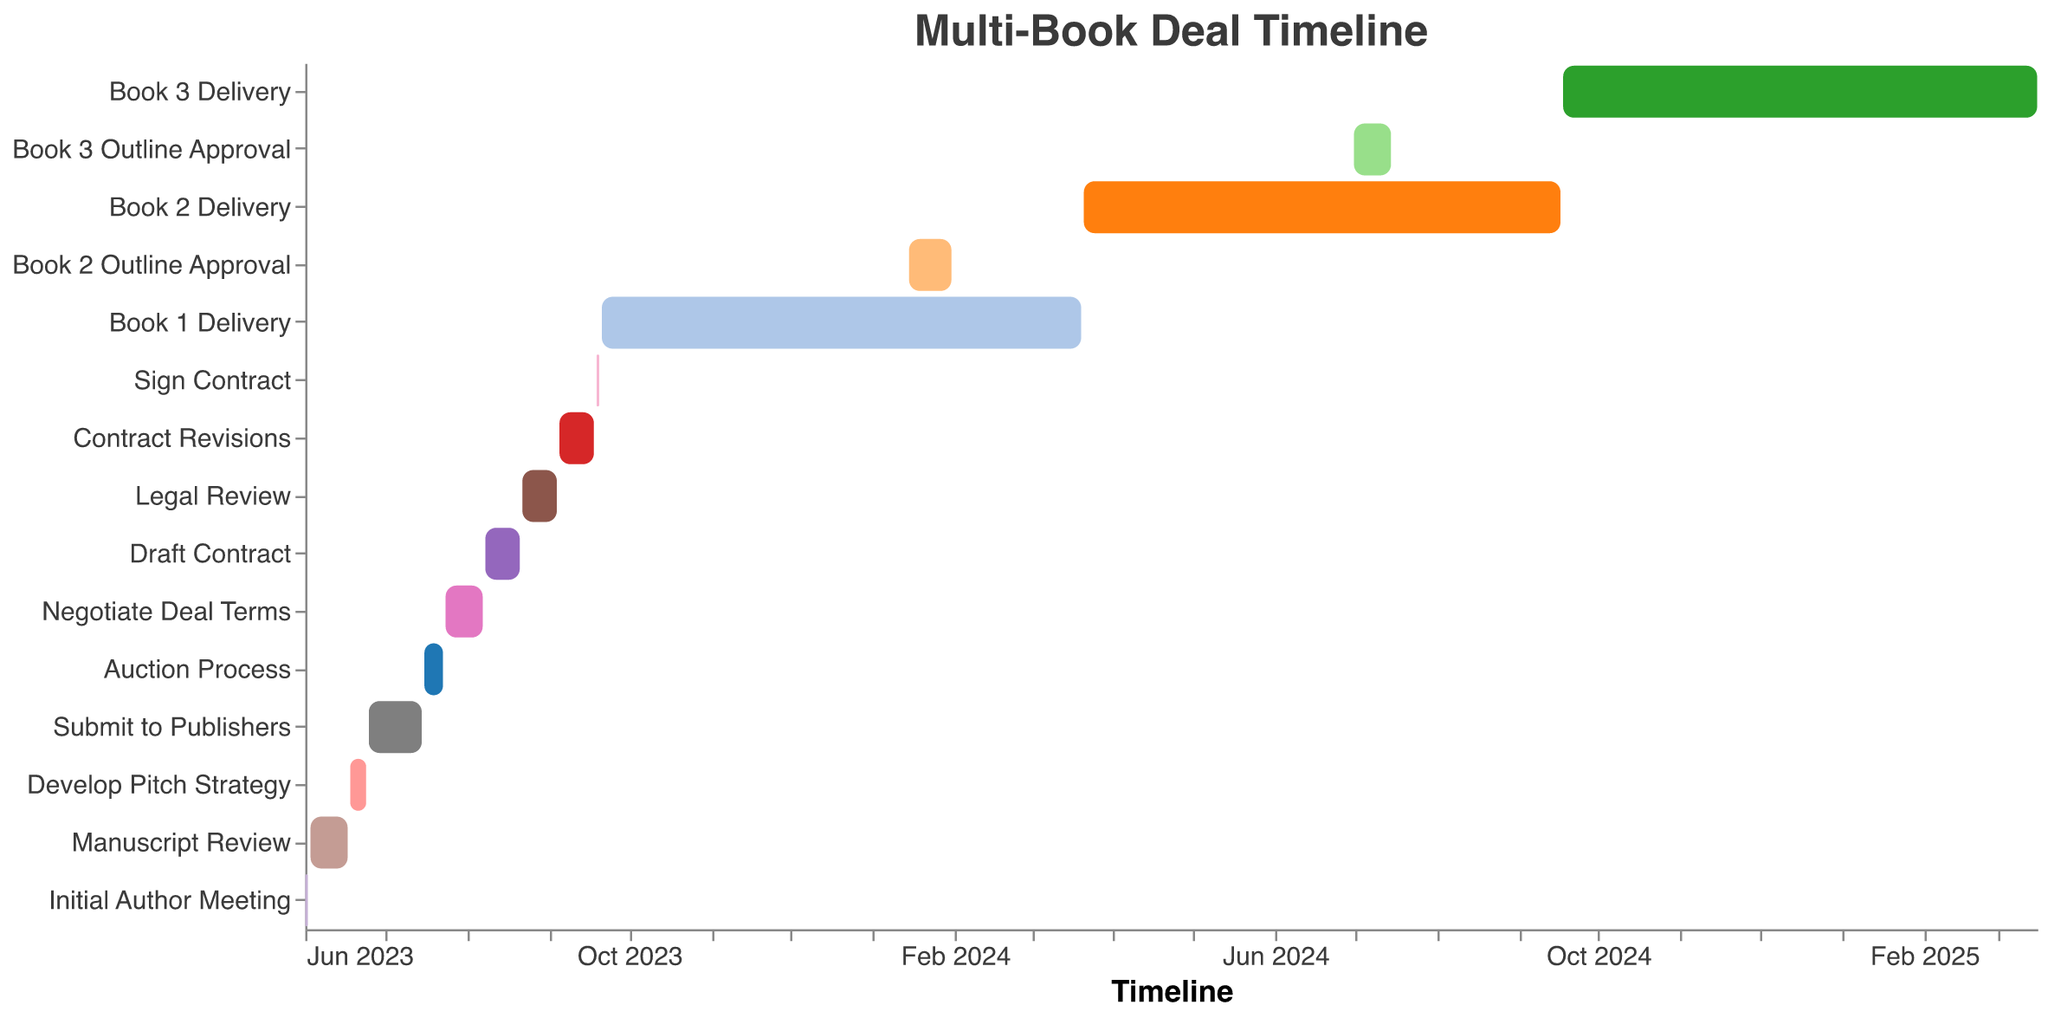What is the title of the figure? The title of the figure is displayed at the top.
Answer: Multi-Book Deal Timeline Which task occurs first in the timeline? The task that starts on the earliest date appears first on the timeline.
Answer: Initial Author Meeting How long does the 'Manuscript Review' stage last? The 'Manuscript Review' stage starts on 2023-06-03 and ends on 2023-06-17. The duration can be calculated by counting the days between these dates.
Answer: 14 days Which tasks overlap with the 'Book 1 Delivery' stage? To find tasks that overlap, check which tasks have start and end dates that fall within the 'Book 1 Delivery' period from 2023-09-21 to 2024-03-20.
Answer: Book 2 Outline Approval What tasks follow directly after signing the contract? Locate the 'Sign Contract' task on the timeline and identify the tasks that start immediately after 2023-09-20.
Answer: Book 1 Delivery What is the time gap between 'Auction Process' and 'Negotiate Deal Terms'? 'Auction Process' ends on 2023-07-23 and 'Negotiate Deal Terms' starts on 2023-07-24. The time gap is the difference between these dates.
Answer: 1 day Which task takes the longest duration to complete, and how long is it? To determine the longest task, compare durations of all tasks. 'Book 3 Delivery' spans from 2024-09-18 to 2025-03-16.
Answer: Book 3 Delivery, 180 days Compare the duration of 'Draft Contract' with 'Legal Review'. Which one is shorter and by how many days? 'Draft Contract' runs from 2023-08-08 to 2023-08-21 (14 days), while 'Legal Review' spans from 2023-08-22 to 2023-09-04 (13 days). Subtract the shorter duration from the longer one.
Answer: Legal Review is shorter by 1 day When does the 'Book 2 Outline Approval' start relative to 'Book 1 Delivery'? 'Book 2 Outline Approval' begins on 2024-01-15, and 'Book 1 Delivery' spans from 2023-09-21 to 2024-03-20. 'Book 2 Outline Approval' starts within this period.
Answer: Within 'Book 1 Delivery' What is the average duration of the stages from 'Initial Author Meeting' to 'Sign Contract'? Sum up the durations of these stages and divide by the number of stages. Each stage’s duration is calculated in days.
Answer: 9.1 days 